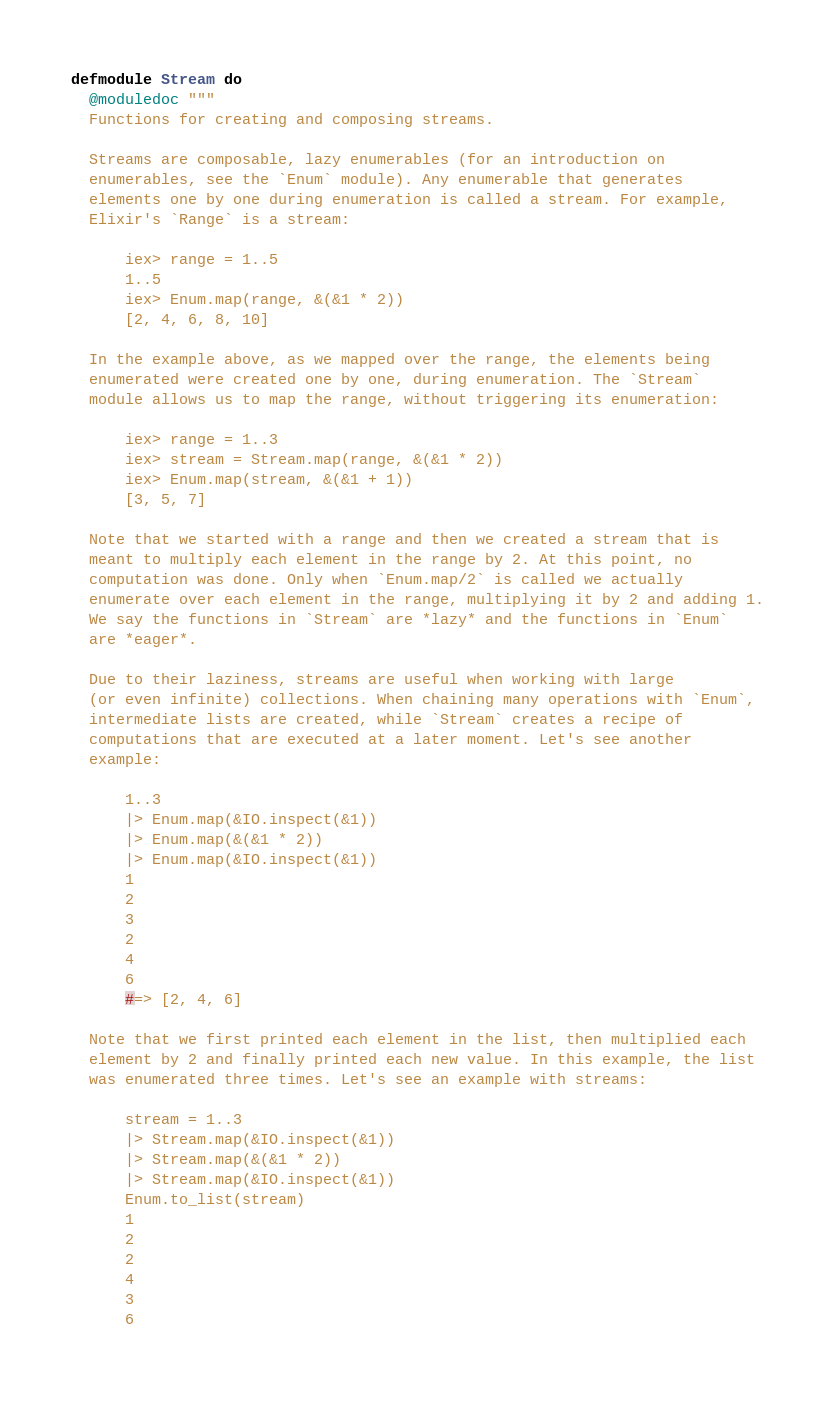Convert code to text. <code><loc_0><loc_0><loc_500><loc_500><_Elixir_>defmodule Stream do
  @moduledoc """
  Functions for creating and composing streams.

  Streams are composable, lazy enumerables (for an introduction on
  enumerables, see the `Enum` module). Any enumerable that generates
  elements one by one during enumeration is called a stream. For example,
  Elixir's `Range` is a stream:

      iex> range = 1..5
      1..5
      iex> Enum.map(range, &(&1 * 2))
      [2, 4, 6, 8, 10]

  In the example above, as we mapped over the range, the elements being
  enumerated were created one by one, during enumeration. The `Stream`
  module allows us to map the range, without triggering its enumeration:

      iex> range = 1..3
      iex> stream = Stream.map(range, &(&1 * 2))
      iex> Enum.map(stream, &(&1 + 1))
      [3, 5, 7]

  Note that we started with a range and then we created a stream that is
  meant to multiply each element in the range by 2. At this point, no
  computation was done. Only when `Enum.map/2` is called we actually
  enumerate over each element in the range, multiplying it by 2 and adding 1.
  We say the functions in `Stream` are *lazy* and the functions in `Enum`
  are *eager*.

  Due to their laziness, streams are useful when working with large
  (or even infinite) collections. When chaining many operations with `Enum`,
  intermediate lists are created, while `Stream` creates a recipe of
  computations that are executed at a later moment. Let's see another
  example:

      1..3
      |> Enum.map(&IO.inspect(&1))
      |> Enum.map(&(&1 * 2))
      |> Enum.map(&IO.inspect(&1))
      1
      2
      3
      2
      4
      6
      #=> [2, 4, 6]

  Note that we first printed each element in the list, then multiplied each
  element by 2 and finally printed each new value. In this example, the list
  was enumerated three times. Let's see an example with streams:

      stream = 1..3
      |> Stream.map(&IO.inspect(&1))
      |> Stream.map(&(&1 * 2))
      |> Stream.map(&IO.inspect(&1))
      Enum.to_list(stream)
      1
      2
      2
      4
      3
      6</code> 